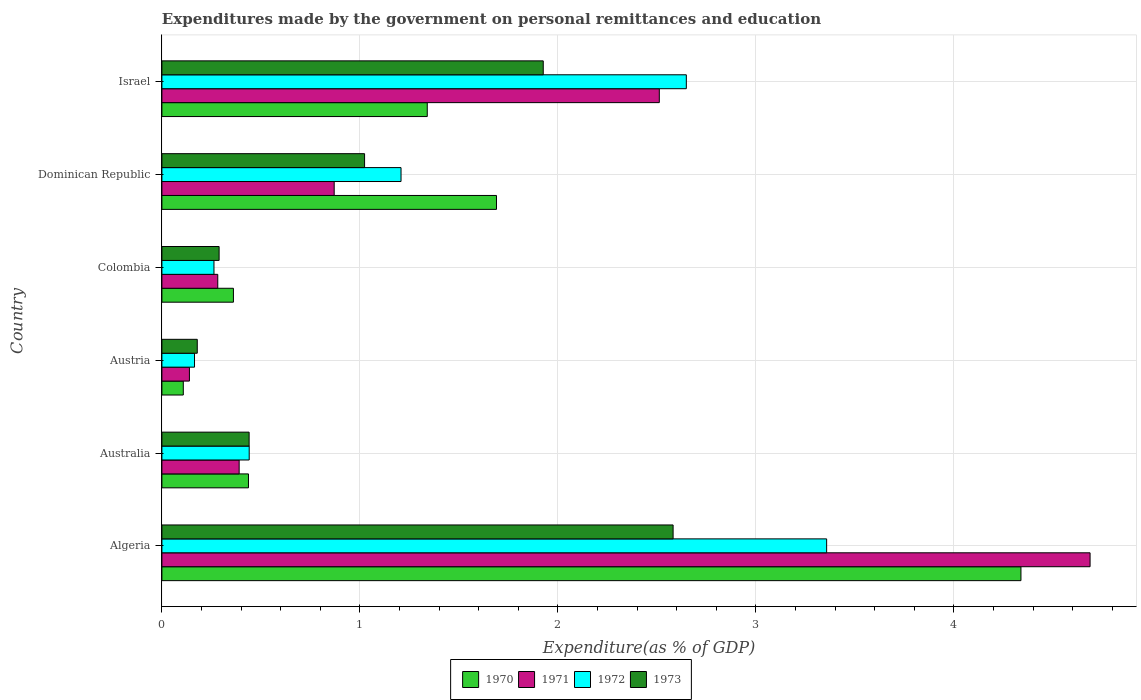How many different coloured bars are there?
Ensure brevity in your answer.  4. How many groups of bars are there?
Provide a short and direct response. 6. Are the number of bars per tick equal to the number of legend labels?
Provide a short and direct response. Yes. Are the number of bars on each tick of the Y-axis equal?
Ensure brevity in your answer.  Yes. How many bars are there on the 1st tick from the bottom?
Make the answer very short. 4. In how many cases, is the number of bars for a given country not equal to the number of legend labels?
Offer a very short reply. 0. What is the expenditures made by the government on personal remittances and education in 1970 in Austria?
Offer a terse response. 0.11. Across all countries, what is the maximum expenditures made by the government on personal remittances and education in 1973?
Keep it short and to the point. 2.58. Across all countries, what is the minimum expenditures made by the government on personal remittances and education in 1972?
Your answer should be compact. 0.16. In which country was the expenditures made by the government on personal remittances and education in 1970 maximum?
Ensure brevity in your answer.  Algeria. What is the total expenditures made by the government on personal remittances and education in 1970 in the graph?
Ensure brevity in your answer.  8.27. What is the difference between the expenditures made by the government on personal remittances and education in 1973 in Dominican Republic and that in Israel?
Make the answer very short. -0.9. What is the difference between the expenditures made by the government on personal remittances and education in 1970 in Dominican Republic and the expenditures made by the government on personal remittances and education in 1972 in Algeria?
Your response must be concise. -1.67. What is the average expenditures made by the government on personal remittances and education in 1970 per country?
Offer a very short reply. 1.38. What is the difference between the expenditures made by the government on personal remittances and education in 1973 and expenditures made by the government on personal remittances and education in 1970 in Israel?
Provide a succinct answer. 0.59. In how many countries, is the expenditures made by the government on personal remittances and education in 1971 greater than 3.6 %?
Provide a short and direct response. 1. What is the ratio of the expenditures made by the government on personal remittances and education in 1973 in Colombia to that in Dominican Republic?
Ensure brevity in your answer.  0.28. What is the difference between the highest and the second highest expenditures made by the government on personal remittances and education in 1971?
Offer a very short reply. 2.18. What is the difference between the highest and the lowest expenditures made by the government on personal remittances and education in 1971?
Keep it short and to the point. 4.55. In how many countries, is the expenditures made by the government on personal remittances and education in 1971 greater than the average expenditures made by the government on personal remittances and education in 1971 taken over all countries?
Ensure brevity in your answer.  2. Is the sum of the expenditures made by the government on personal remittances and education in 1971 in Colombia and Israel greater than the maximum expenditures made by the government on personal remittances and education in 1972 across all countries?
Your answer should be compact. No. Is it the case that in every country, the sum of the expenditures made by the government on personal remittances and education in 1971 and expenditures made by the government on personal remittances and education in 1973 is greater than the sum of expenditures made by the government on personal remittances and education in 1970 and expenditures made by the government on personal remittances and education in 1972?
Offer a very short reply. No. Is it the case that in every country, the sum of the expenditures made by the government on personal remittances and education in 1971 and expenditures made by the government on personal remittances and education in 1973 is greater than the expenditures made by the government on personal remittances and education in 1972?
Give a very brief answer. Yes. How many countries are there in the graph?
Give a very brief answer. 6. What is the difference between two consecutive major ticks on the X-axis?
Provide a succinct answer. 1. Are the values on the major ticks of X-axis written in scientific E-notation?
Your response must be concise. No. Does the graph contain any zero values?
Offer a terse response. No. Does the graph contain grids?
Your response must be concise. Yes. Where does the legend appear in the graph?
Your answer should be compact. Bottom center. How many legend labels are there?
Ensure brevity in your answer.  4. How are the legend labels stacked?
Ensure brevity in your answer.  Horizontal. What is the title of the graph?
Your answer should be very brief. Expenditures made by the government on personal remittances and education. What is the label or title of the X-axis?
Offer a very short reply. Expenditure(as % of GDP). What is the label or title of the Y-axis?
Your response must be concise. Country. What is the Expenditure(as % of GDP) of 1970 in Algeria?
Offer a terse response. 4.34. What is the Expenditure(as % of GDP) in 1971 in Algeria?
Keep it short and to the point. 4.69. What is the Expenditure(as % of GDP) of 1972 in Algeria?
Provide a succinct answer. 3.36. What is the Expenditure(as % of GDP) of 1973 in Algeria?
Make the answer very short. 2.58. What is the Expenditure(as % of GDP) in 1970 in Australia?
Your response must be concise. 0.44. What is the Expenditure(as % of GDP) of 1971 in Australia?
Keep it short and to the point. 0.39. What is the Expenditure(as % of GDP) of 1972 in Australia?
Keep it short and to the point. 0.44. What is the Expenditure(as % of GDP) of 1973 in Australia?
Your answer should be very brief. 0.44. What is the Expenditure(as % of GDP) of 1970 in Austria?
Provide a succinct answer. 0.11. What is the Expenditure(as % of GDP) in 1971 in Austria?
Offer a terse response. 0.14. What is the Expenditure(as % of GDP) in 1972 in Austria?
Offer a very short reply. 0.16. What is the Expenditure(as % of GDP) of 1973 in Austria?
Your answer should be very brief. 0.18. What is the Expenditure(as % of GDP) of 1970 in Colombia?
Provide a short and direct response. 0.36. What is the Expenditure(as % of GDP) in 1971 in Colombia?
Your response must be concise. 0.28. What is the Expenditure(as % of GDP) of 1972 in Colombia?
Your response must be concise. 0.26. What is the Expenditure(as % of GDP) of 1973 in Colombia?
Offer a terse response. 0.29. What is the Expenditure(as % of GDP) of 1970 in Dominican Republic?
Keep it short and to the point. 1.69. What is the Expenditure(as % of GDP) in 1971 in Dominican Republic?
Provide a short and direct response. 0.87. What is the Expenditure(as % of GDP) of 1972 in Dominican Republic?
Offer a terse response. 1.21. What is the Expenditure(as % of GDP) in 1973 in Dominican Republic?
Provide a succinct answer. 1.02. What is the Expenditure(as % of GDP) of 1970 in Israel?
Your response must be concise. 1.34. What is the Expenditure(as % of GDP) of 1971 in Israel?
Give a very brief answer. 2.51. What is the Expenditure(as % of GDP) of 1972 in Israel?
Your answer should be compact. 2.65. What is the Expenditure(as % of GDP) in 1973 in Israel?
Provide a short and direct response. 1.93. Across all countries, what is the maximum Expenditure(as % of GDP) of 1970?
Provide a short and direct response. 4.34. Across all countries, what is the maximum Expenditure(as % of GDP) in 1971?
Offer a terse response. 4.69. Across all countries, what is the maximum Expenditure(as % of GDP) of 1972?
Your response must be concise. 3.36. Across all countries, what is the maximum Expenditure(as % of GDP) in 1973?
Your response must be concise. 2.58. Across all countries, what is the minimum Expenditure(as % of GDP) in 1970?
Keep it short and to the point. 0.11. Across all countries, what is the minimum Expenditure(as % of GDP) of 1971?
Provide a succinct answer. 0.14. Across all countries, what is the minimum Expenditure(as % of GDP) in 1972?
Offer a very short reply. 0.16. Across all countries, what is the minimum Expenditure(as % of GDP) in 1973?
Your response must be concise. 0.18. What is the total Expenditure(as % of GDP) of 1970 in the graph?
Keep it short and to the point. 8.27. What is the total Expenditure(as % of GDP) in 1971 in the graph?
Keep it short and to the point. 8.88. What is the total Expenditure(as % of GDP) in 1972 in the graph?
Keep it short and to the point. 8.08. What is the total Expenditure(as % of GDP) of 1973 in the graph?
Your response must be concise. 6.44. What is the difference between the Expenditure(as % of GDP) of 1970 in Algeria and that in Australia?
Give a very brief answer. 3.9. What is the difference between the Expenditure(as % of GDP) in 1971 in Algeria and that in Australia?
Ensure brevity in your answer.  4.3. What is the difference between the Expenditure(as % of GDP) of 1972 in Algeria and that in Australia?
Your answer should be compact. 2.92. What is the difference between the Expenditure(as % of GDP) in 1973 in Algeria and that in Australia?
Offer a very short reply. 2.14. What is the difference between the Expenditure(as % of GDP) in 1970 in Algeria and that in Austria?
Give a very brief answer. 4.23. What is the difference between the Expenditure(as % of GDP) in 1971 in Algeria and that in Austria?
Ensure brevity in your answer.  4.55. What is the difference between the Expenditure(as % of GDP) in 1972 in Algeria and that in Austria?
Provide a succinct answer. 3.19. What is the difference between the Expenditure(as % of GDP) of 1973 in Algeria and that in Austria?
Provide a short and direct response. 2.4. What is the difference between the Expenditure(as % of GDP) in 1970 in Algeria and that in Colombia?
Your answer should be compact. 3.98. What is the difference between the Expenditure(as % of GDP) of 1971 in Algeria and that in Colombia?
Keep it short and to the point. 4.41. What is the difference between the Expenditure(as % of GDP) in 1972 in Algeria and that in Colombia?
Ensure brevity in your answer.  3.09. What is the difference between the Expenditure(as % of GDP) of 1973 in Algeria and that in Colombia?
Ensure brevity in your answer.  2.29. What is the difference between the Expenditure(as % of GDP) in 1970 in Algeria and that in Dominican Republic?
Give a very brief answer. 2.65. What is the difference between the Expenditure(as % of GDP) of 1971 in Algeria and that in Dominican Republic?
Provide a short and direct response. 3.82. What is the difference between the Expenditure(as % of GDP) in 1972 in Algeria and that in Dominican Republic?
Give a very brief answer. 2.15. What is the difference between the Expenditure(as % of GDP) of 1973 in Algeria and that in Dominican Republic?
Your answer should be compact. 1.56. What is the difference between the Expenditure(as % of GDP) in 1970 in Algeria and that in Israel?
Give a very brief answer. 3. What is the difference between the Expenditure(as % of GDP) in 1971 in Algeria and that in Israel?
Give a very brief answer. 2.18. What is the difference between the Expenditure(as % of GDP) of 1972 in Algeria and that in Israel?
Keep it short and to the point. 0.71. What is the difference between the Expenditure(as % of GDP) in 1973 in Algeria and that in Israel?
Offer a terse response. 0.66. What is the difference between the Expenditure(as % of GDP) in 1970 in Australia and that in Austria?
Make the answer very short. 0.33. What is the difference between the Expenditure(as % of GDP) of 1971 in Australia and that in Austria?
Ensure brevity in your answer.  0.25. What is the difference between the Expenditure(as % of GDP) in 1972 in Australia and that in Austria?
Your response must be concise. 0.28. What is the difference between the Expenditure(as % of GDP) of 1973 in Australia and that in Austria?
Offer a very short reply. 0.26. What is the difference between the Expenditure(as % of GDP) in 1970 in Australia and that in Colombia?
Make the answer very short. 0.08. What is the difference between the Expenditure(as % of GDP) in 1971 in Australia and that in Colombia?
Your answer should be compact. 0.11. What is the difference between the Expenditure(as % of GDP) in 1972 in Australia and that in Colombia?
Offer a very short reply. 0.18. What is the difference between the Expenditure(as % of GDP) in 1973 in Australia and that in Colombia?
Your response must be concise. 0.15. What is the difference between the Expenditure(as % of GDP) in 1970 in Australia and that in Dominican Republic?
Your response must be concise. -1.25. What is the difference between the Expenditure(as % of GDP) in 1971 in Australia and that in Dominican Republic?
Your answer should be compact. -0.48. What is the difference between the Expenditure(as % of GDP) of 1972 in Australia and that in Dominican Republic?
Give a very brief answer. -0.77. What is the difference between the Expenditure(as % of GDP) in 1973 in Australia and that in Dominican Republic?
Offer a terse response. -0.58. What is the difference between the Expenditure(as % of GDP) in 1970 in Australia and that in Israel?
Your answer should be very brief. -0.9. What is the difference between the Expenditure(as % of GDP) in 1971 in Australia and that in Israel?
Ensure brevity in your answer.  -2.12. What is the difference between the Expenditure(as % of GDP) of 1972 in Australia and that in Israel?
Offer a very short reply. -2.21. What is the difference between the Expenditure(as % of GDP) of 1973 in Australia and that in Israel?
Give a very brief answer. -1.49. What is the difference between the Expenditure(as % of GDP) in 1970 in Austria and that in Colombia?
Offer a terse response. -0.25. What is the difference between the Expenditure(as % of GDP) of 1971 in Austria and that in Colombia?
Keep it short and to the point. -0.14. What is the difference between the Expenditure(as % of GDP) of 1972 in Austria and that in Colombia?
Offer a very short reply. -0.1. What is the difference between the Expenditure(as % of GDP) of 1973 in Austria and that in Colombia?
Keep it short and to the point. -0.11. What is the difference between the Expenditure(as % of GDP) in 1970 in Austria and that in Dominican Republic?
Keep it short and to the point. -1.58. What is the difference between the Expenditure(as % of GDP) of 1971 in Austria and that in Dominican Republic?
Your answer should be very brief. -0.73. What is the difference between the Expenditure(as % of GDP) of 1972 in Austria and that in Dominican Republic?
Your answer should be compact. -1.04. What is the difference between the Expenditure(as % of GDP) of 1973 in Austria and that in Dominican Republic?
Provide a succinct answer. -0.84. What is the difference between the Expenditure(as % of GDP) of 1970 in Austria and that in Israel?
Offer a terse response. -1.23. What is the difference between the Expenditure(as % of GDP) of 1971 in Austria and that in Israel?
Your answer should be compact. -2.37. What is the difference between the Expenditure(as % of GDP) in 1972 in Austria and that in Israel?
Keep it short and to the point. -2.48. What is the difference between the Expenditure(as % of GDP) of 1973 in Austria and that in Israel?
Your answer should be very brief. -1.75. What is the difference between the Expenditure(as % of GDP) in 1970 in Colombia and that in Dominican Republic?
Make the answer very short. -1.33. What is the difference between the Expenditure(as % of GDP) of 1971 in Colombia and that in Dominican Republic?
Give a very brief answer. -0.59. What is the difference between the Expenditure(as % of GDP) of 1972 in Colombia and that in Dominican Republic?
Your response must be concise. -0.94. What is the difference between the Expenditure(as % of GDP) of 1973 in Colombia and that in Dominican Republic?
Keep it short and to the point. -0.73. What is the difference between the Expenditure(as % of GDP) in 1970 in Colombia and that in Israel?
Give a very brief answer. -0.98. What is the difference between the Expenditure(as % of GDP) in 1971 in Colombia and that in Israel?
Keep it short and to the point. -2.23. What is the difference between the Expenditure(as % of GDP) in 1972 in Colombia and that in Israel?
Your answer should be compact. -2.39. What is the difference between the Expenditure(as % of GDP) of 1973 in Colombia and that in Israel?
Ensure brevity in your answer.  -1.64. What is the difference between the Expenditure(as % of GDP) of 1970 in Dominican Republic and that in Israel?
Your answer should be very brief. 0.35. What is the difference between the Expenditure(as % of GDP) of 1971 in Dominican Republic and that in Israel?
Offer a terse response. -1.64. What is the difference between the Expenditure(as % of GDP) of 1972 in Dominican Republic and that in Israel?
Ensure brevity in your answer.  -1.44. What is the difference between the Expenditure(as % of GDP) in 1973 in Dominican Republic and that in Israel?
Ensure brevity in your answer.  -0.9. What is the difference between the Expenditure(as % of GDP) of 1970 in Algeria and the Expenditure(as % of GDP) of 1971 in Australia?
Your answer should be compact. 3.95. What is the difference between the Expenditure(as % of GDP) in 1970 in Algeria and the Expenditure(as % of GDP) in 1972 in Australia?
Make the answer very short. 3.9. What is the difference between the Expenditure(as % of GDP) of 1970 in Algeria and the Expenditure(as % of GDP) of 1973 in Australia?
Provide a succinct answer. 3.9. What is the difference between the Expenditure(as % of GDP) in 1971 in Algeria and the Expenditure(as % of GDP) in 1972 in Australia?
Provide a short and direct response. 4.25. What is the difference between the Expenditure(as % of GDP) of 1971 in Algeria and the Expenditure(as % of GDP) of 1973 in Australia?
Ensure brevity in your answer.  4.25. What is the difference between the Expenditure(as % of GDP) in 1972 in Algeria and the Expenditure(as % of GDP) in 1973 in Australia?
Ensure brevity in your answer.  2.92. What is the difference between the Expenditure(as % of GDP) of 1970 in Algeria and the Expenditure(as % of GDP) of 1971 in Austria?
Give a very brief answer. 4.2. What is the difference between the Expenditure(as % of GDP) of 1970 in Algeria and the Expenditure(as % of GDP) of 1972 in Austria?
Provide a succinct answer. 4.17. What is the difference between the Expenditure(as % of GDP) of 1970 in Algeria and the Expenditure(as % of GDP) of 1973 in Austria?
Ensure brevity in your answer.  4.16. What is the difference between the Expenditure(as % of GDP) in 1971 in Algeria and the Expenditure(as % of GDP) in 1972 in Austria?
Offer a terse response. 4.52. What is the difference between the Expenditure(as % of GDP) of 1971 in Algeria and the Expenditure(as % of GDP) of 1973 in Austria?
Keep it short and to the point. 4.51. What is the difference between the Expenditure(as % of GDP) in 1972 in Algeria and the Expenditure(as % of GDP) in 1973 in Austria?
Offer a very short reply. 3.18. What is the difference between the Expenditure(as % of GDP) in 1970 in Algeria and the Expenditure(as % of GDP) in 1971 in Colombia?
Ensure brevity in your answer.  4.06. What is the difference between the Expenditure(as % of GDP) of 1970 in Algeria and the Expenditure(as % of GDP) of 1972 in Colombia?
Ensure brevity in your answer.  4.08. What is the difference between the Expenditure(as % of GDP) of 1970 in Algeria and the Expenditure(as % of GDP) of 1973 in Colombia?
Offer a very short reply. 4.05. What is the difference between the Expenditure(as % of GDP) of 1971 in Algeria and the Expenditure(as % of GDP) of 1972 in Colombia?
Your answer should be compact. 4.42. What is the difference between the Expenditure(as % of GDP) of 1971 in Algeria and the Expenditure(as % of GDP) of 1973 in Colombia?
Your answer should be very brief. 4.4. What is the difference between the Expenditure(as % of GDP) in 1972 in Algeria and the Expenditure(as % of GDP) in 1973 in Colombia?
Provide a succinct answer. 3.07. What is the difference between the Expenditure(as % of GDP) in 1970 in Algeria and the Expenditure(as % of GDP) in 1971 in Dominican Republic?
Give a very brief answer. 3.47. What is the difference between the Expenditure(as % of GDP) in 1970 in Algeria and the Expenditure(as % of GDP) in 1972 in Dominican Republic?
Provide a succinct answer. 3.13. What is the difference between the Expenditure(as % of GDP) in 1970 in Algeria and the Expenditure(as % of GDP) in 1973 in Dominican Republic?
Make the answer very short. 3.31. What is the difference between the Expenditure(as % of GDP) in 1971 in Algeria and the Expenditure(as % of GDP) in 1972 in Dominican Republic?
Ensure brevity in your answer.  3.48. What is the difference between the Expenditure(as % of GDP) of 1971 in Algeria and the Expenditure(as % of GDP) of 1973 in Dominican Republic?
Make the answer very short. 3.66. What is the difference between the Expenditure(as % of GDP) of 1972 in Algeria and the Expenditure(as % of GDP) of 1973 in Dominican Republic?
Give a very brief answer. 2.33. What is the difference between the Expenditure(as % of GDP) of 1970 in Algeria and the Expenditure(as % of GDP) of 1971 in Israel?
Give a very brief answer. 1.83. What is the difference between the Expenditure(as % of GDP) of 1970 in Algeria and the Expenditure(as % of GDP) of 1972 in Israel?
Give a very brief answer. 1.69. What is the difference between the Expenditure(as % of GDP) of 1970 in Algeria and the Expenditure(as % of GDP) of 1973 in Israel?
Provide a succinct answer. 2.41. What is the difference between the Expenditure(as % of GDP) in 1971 in Algeria and the Expenditure(as % of GDP) in 1972 in Israel?
Make the answer very short. 2.04. What is the difference between the Expenditure(as % of GDP) in 1971 in Algeria and the Expenditure(as % of GDP) in 1973 in Israel?
Offer a very short reply. 2.76. What is the difference between the Expenditure(as % of GDP) in 1972 in Algeria and the Expenditure(as % of GDP) in 1973 in Israel?
Ensure brevity in your answer.  1.43. What is the difference between the Expenditure(as % of GDP) of 1970 in Australia and the Expenditure(as % of GDP) of 1971 in Austria?
Provide a succinct answer. 0.3. What is the difference between the Expenditure(as % of GDP) in 1970 in Australia and the Expenditure(as % of GDP) in 1972 in Austria?
Your response must be concise. 0.27. What is the difference between the Expenditure(as % of GDP) of 1970 in Australia and the Expenditure(as % of GDP) of 1973 in Austria?
Your answer should be compact. 0.26. What is the difference between the Expenditure(as % of GDP) in 1971 in Australia and the Expenditure(as % of GDP) in 1972 in Austria?
Make the answer very short. 0.23. What is the difference between the Expenditure(as % of GDP) of 1971 in Australia and the Expenditure(as % of GDP) of 1973 in Austria?
Ensure brevity in your answer.  0.21. What is the difference between the Expenditure(as % of GDP) in 1972 in Australia and the Expenditure(as % of GDP) in 1973 in Austria?
Give a very brief answer. 0.26. What is the difference between the Expenditure(as % of GDP) in 1970 in Australia and the Expenditure(as % of GDP) in 1971 in Colombia?
Your answer should be compact. 0.15. What is the difference between the Expenditure(as % of GDP) in 1970 in Australia and the Expenditure(as % of GDP) in 1972 in Colombia?
Keep it short and to the point. 0.17. What is the difference between the Expenditure(as % of GDP) of 1970 in Australia and the Expenditure(as % of GDP) of 1973 in Colombia?
Provide a succinct answer. 0.15. What is the difference between the Expenditure(as % of GDP) of 1971 in Australia and the Expenditure(as % of GDP) of 1972 in Colombia?
Your response must be concise. 0.13. What is the difference between the Expenditure(as % of GDP) in 1971 in Australia and the Expenditure(as % of GDP) in 1973 in Colombia?
Your answer should be compact. 0.1. What is the difference between the Expenditure(as % of GDP) in 1972 in Australia and the Expenditure(as % of GDP) in 1973 in Colombia?
Make the answer very short. 0.15. What is the difference between the Expenditure(as % of GDP) in 1970 in Australia and the Expenditure(as % of GDP) in 1971 in Dominican Republic?
Offer a terse response. -0.43. What is the difference between the Expenditure(as % of GDP) in 1970 in Australia and the Expenditure(as % of GDP) in 1972 in Dominican Republic?
Provide a short and direct response. -0.77. What is the difference between the Expenditure(as % of GDP) in 1970 in Australia and the Expenditure(as % of GDP) in 1973 in Dominican Republic?
Give a very brief answer. -0.59. What is the difference between the Expenditure(as % of GDP) in 1971 in Australia and the Expenditure(as % of GDP) in 1972 in Dominican Republic?
Provide a short and direct response. -0.82. What is the difference between the Expenditure(as % of GDP) in 1971 in Australia and the Expenditure(as % of GDP) in 1973 in Dominican Republic?
Make the answer very short. -0.63. What is the difference between the Expenditure(as % of GDP) of 1972 in Australia and the Expenditure(as % of GDP) of 1973 in Dominican Republic?
Your answer should be very brief. -0.58. What is the difference between the Expenditure(as % of GDP) in 1970 in Australia and the Expenditure(as % of GDP) in 1971 in Israel?
Make the answer very short. -2.07. What is the difference between the Expenditure(as % of GDP) of 1970 in Australia and the Expenditure(as % of GDP) of 1972 in Israel?
Give a very brief answer. -2.21. What is the difference between the Expenditure(as % of GDP) of 1970 in Australia and the Expenditure(as % of GDP) of 1973 in Israel?
Provide a short and direct response. -1.49. What is the difference between the Expenditure(as % of GDP) in 1971 in Australia and the Expenditure(as % of GDP) in 1972 in Israel?
Provide a short and direct response. -2.26. What is the difference between the Expenditure(as % of GDP) of 1971 in Australia and the Expenditure(as % of GDP) of 1973 in Israel?
Give a very brief answer. -1.54. What is the difference between the Expenditure(as % of GDP) of 1972 in Australia and the Expenditure(as % of GDP) of 1973 in Israel?
Make the answer very short. -1.49. What is the difference between the Expenditure(as % of GDP) in 1970 in Austria and the Expenditure(as % of GDP) in 1971 in Colombia?
Your answer should be compact. -0.17. What is the difference between the Expenditure(as % of GDP) in 1970 in Austria and the Expenditure(as % of GDP) in 1972 in Colombia?
Your answer should be very brief. -0.15. What is the difference between the Expenditure(as % of GDP) in 1970 in Austria and the Expenditure(as % of GDP) in 1973 in Colombia?
Your response must be concise. -0.18. What is the difference between the Expenditure(as % of GDP) in 1971 in Austria and the Expenditure(as % of GDP) in 1972 in Colombia?
Provide a succinct answer. -0.12. What is the difference between the Expenditure(as % of GDP) of 1971 in Austria and the Expenditure(as % of GDP) of 1973 in Colombia?
Make the answer very short. -0.15. What is the difference between the Expenditure(as % of GDP) in 1972 in Austria and the Expenditure(as % of GDP) in 1973 in Colombia?
Offer a terse response. -0.12. What is the difference between the Expenditure(as % of GDP) of 1970 in Austria and the Expenditure(as % of GDP) of 1971 in Dominican Republic?
Provide a succinct answer. -0.76. What is the difference between the Expenditure(as % of GDP) in 1970 in Austria and the Expenditure(as % of GDP) in 1972 in Dominican Republic?
Make the answer very short. -1.1. What is the difference between the Expenditure(as % of GDP) in 1970 in Austria and the Expenditure(as % of GDP) in 1973 in Dominican Republic?
Ensure brevity in your answer.  -0.92. What is the difference between the Expenditure(as % of GDP) of 1971 in Austria and the Expenditure(as % of GDP) of 1972 in Dominican Republic?
Offer a terse response. -1.07. What is the difference between the Expenditure(as % of GDP) in 1971 in Austria and the Expenditure(as % of GDP) in 1973 in Dominican Republic?
Give a very brief answer. -0.88. What is the difference between the Expenditure(as % of GDP) of 1972 in Austria and the Expenditure(as % of GDP) of 1973 in Dominican Republic?
Give a very brief answer. -0.86. What is the difference between the Expenditure(as % of GDP) of 1970 in Austria and the Expenditure(as % of GDP) of 1971 in Israel?
Provide a short and direct response. -2.4. What is the difference between the Expenditure(as % of GDP) in 1970 in Austria and the Expenditure(as % of GDP) in 1972 in Israel?
Ensure brevity in your answer.  -2.54. What is the difference between the Expenditure(as % of GDP) of 1970 in Austria and the Expenditure(as % of GDP) of 1973 in Israel?
Offer a terse response. -1.82. What is the difference between the Expenditure(as % of GDP) of 1971 in Austria and the Expenditure(as % of GDP) of 1972 in Israel?
Provide a succinct answer. -2.51. What is the difference between the Expenditure(as % of GDP) of 1971 in Austria and the Expenditure(as % of GDP) of 1973 in Israel?
Your answer should be very brief. -1.79. What is the difference between the Expenditure(as % of GDP) of 1972 in Austria and the Expenditure(as % of GDP) of 1973 in Israel?
Keep it short and to the point. -1.76. What is the difference between the Expenditure(as % of GDP) in 1970 in Colombia and the Expenditure(as % of GDP) in 1971 in Dominican Republic?
Your answer should be very brief. -0.51. What is the difference between the Expenditure(as % of GDP) in 1970 in Colombia and the Expenditure(as % of GDP) in 1972 in Dominican Republic?
Give a very brief answer. -0.85. What is the difference between the Expenditure(as % of GDP) in 1970 in Colombia and the Expenditure(as % of GDP) in 1973 in Dominican Republic?
Make the answer very short. -0.66. What is the difference between the Expenditure(as % of GDP) in 1971 in Colombia and the Expenditure(as % of GDP) in 1972 in Dominican Republic?
Make the answer very short. -0.93. What is the difference between the Expenditure(as % of GDP) in 1971 in Colombia and the Expenditure(as % of GDP) in 1973 in Dominican Republic?
Offer a very short reply. -0.74. What is the difference between the Expenditure(as % of GDP) of 1972 in Colombia and the Expenditure(as % of GDP) of 1973 in Dominican Republic?
Ensure brevity in your answer.  -0.76. What is the difference between the Expenditure(as % of GDP) in 1970 in Colombia and the Expenditure(as % of GDP) in 1971 in Israel?
Make the answer very short. -2.15. What is the difference between the Expenditure(as % of GDP) in 1970 in Colombia and the Expenditure(as % of GDP) in 1972 in Israel?
Give a very brief answer. -2.29. What is the difference between the Expenditure(as % of GDP) of 1970 in Colombia and the Expenditure(as % of GDP) of 1973 in Israel?
Offer a very short reply. -1.56. What is the difference between the Expenditure(as % of GDP) of 1971 in Colombia and the Expenditure(as % of GDP) of 1972 in Israel?
Offer a terse response. -2.37. What is the difference between the Expenditure(as % of GDP) in 1971 in Colombia and the Expenditure(as % of GDP) in 1973 in Israel?
Offer a very short reply. -1.64. What is the difference between the Expenditure(as % of GDP) of 1972 in Colombia and the Expenditure(as % of GDP) of 1973 in Israel?
Offer a very short reply. -1.66. What is the difference between the Expenditure(as % of GDP) of 1970 in Dominican Republic and the Expenditure(as % of GDP) of 1971 in Israel?
Ensure brevity in your answer.  -0.82. What is the difference between the Expenditure(as % of GDP) of 1970 in Dominican Republic and the Expenditure(as % of GDP) of 1972 in Israel?
Provide a succinct answer. -0.96. What is the difference between the Expenditure(as % of GDP) in 1970 in Dominican Republic and the Expenditure(as % of GDP) in 1973 in Israel?
Provide a short and direct response. -0.24. What is the difference between the Expenditure(as % of GDP) of 1971 in Dominican Republic and the Expenditure(as % of GDP) of 1972 in Israel?
Provide a succinct answer. -1.78. What is the difference between the Expenditure(as % of GDP) of 1971 in Dominican Republic and the Expenditure(as % of GDP) of 1973 in Israel?
Keep it short and to the point. -1.06. What is the difference between the Expenditure(as % of GDP) of 1972 in Dominican Republic and the Expenditure(as % of GDP) of 1973 in Israel?
Provide a succinct answer. -0.72. What is the average Expenditure(as % of GDP) of 1970 per country?
Give a very brief answer. 1.38. What is the average Expenditure(as % of GDP) of 1971 per country?
Give a very brief answer. 1.48. What is the average Expenditure(as % of GDP) of 1972 per country?
Your answer should be compact. 1.35. What is the average Expenditure(as % of GDP) in 1973 per country?
Your answer should be compact. 1.07. What is the difference between the Expenditure(as % of GDP) in 1970 and Expenditure(as % of GDP) in 1971 in Algeria?
Provide a short and direct response. -0.35. What is the difference between the Expenditure(as % of GDP) of 1970 and Expenditure(as % of GDP) of 1972 in Algeria?
Offer a terse response. 0.98. What is the difference between the Expenditure(as % of GDP) of 1970 and Expenditure(as % of GDP) of 1973 in Algeria?
Give a very brief answer. 1.76. What is the difference between the Expenditure(as % of GDP) in 1971 and Expenditure(as % of GDP) in 1972 in Algeria?
Offer a very short reply. 1.33. What is the difference between the Expenditure(as % of GDP) in 1971 and Expenditure(as % of GDP) in 1973 in Algeria?
Ensure brevity in your answer.  2.11. What is the difference between the Expenditure(as % of GDP) in 1972 and Expenditure(as % of GDP) in 1973 in Algeria?
Your answer should be very brief. 0.78. What is the difference between the Expenditure(as % of GDP) of 1970 and Expenditure(as % of GDP) of 1971 in Australia?
Your response must be concise. 0.05. What is the difference between the Expenditure(as % of GDP) of 1970 and Expenditure(as % of GDP) of 1972 in Australia?
Provide a short and direct response. -0. What is the difference between the Expenditure(as % of GDP) in 1970 and Expenditure(as % of GDP) in 1973 in Australia?
Make the answer very short. -0. What is the difference between the Expenditure(as % of GDP) of 1971 and Expenditure(as % of GDP) of 1972 in Australia?
Give a very brief answer. -0.05. What is the difference between the Expenditure(as % of GDP) of 1971 and Expenditure(as % of GDP) of 1973 in Australia?
Provide a succinct answer. -0.05. What is the difference between the Expenditure(as % of GDP) of 1972 and Expenditure(as % of GDP) of 1973 in Australia?
Provide a succinct answer. 0. What is the difference between the Expenditure(as % of GDP) in 1970 and Expenditure(as % of GDP) in 1971 in Austria?
Ensure brevity in your answer.  -0.03. What is the difference between the Expenditure(as % of GDP) in 1970 and Expenditure(as % of GDP) in 1972 in Austria?
Give a very brief answer. -0.06. What is the difference between the Expenditure(as % of GDP) of 1970 and Expenditure(as % of GDP) of 1973 in Austria?
Ensure brevity in your answer.  -0.07. What is the difference between the Expenditure(as % of GDP) in 1971 and Expenditure(as % of GDP) in 1972 in Austria?
Provide a succinct answer. -0.03. What is the difference between the Expenditure(as % of GDP) in 1971 and Expenditure(as % of GDP) in 1973 in Austria?
Your response must be concise. -0.04. What is the difference between the Expenditure(as % of GDP) of 1972 and Expenditure(as % of GDP) of 1973 in Austria?
Your answer should be compact. -0.01. What is the difference between the Expenditure(as % of GDP) in 1970 and Expenditure(as % of GDP) in 1971 in Colombia?
Keep it short and to the point. 0.08. What is the difference between the Expenditure(as % of GDP) of 1970 and Expenditure(as % of GDP) of 1972 in Colombia?
Provide a succinct answer. 0.1. What is the difference between the Expenditure(as % of GDP) of 1970 and Expenditure(as % of GDP) of 1973 in Colombia?
Offer a very short reply. 0.07. What is the difference between the Expenditure(as % of GDP) in 1971 and Expenditure(as % of GDP) in 1972 in Colombia?
Make the answer very short. 0.02. What is the difference between the Expenditure(as % of GDP) in 1971 and Expenditure(as % of GDP) in 1973 in Colombia?
Your answer should be very brief. -0.01. What is the difference between the Expenditure(as % of GDP) in 1972 and Expenditure(as % of GDP) in 1973 in Colombia?
Ensure brevity in your answer.  -0.03. What is the difference between the Expenditure(as % of GDP) of 1970 and Expenditure(as % of GDP) of 1971 in Dominican Republic?
Ensure brevity in your answer.  0.82. What is the difference between the Expenditure(as % of GDP) of 1970 and Expenditure(as % of GDP) of 1972 in Dominican Republic?
Provide a succinct answer. 0.48. What is the difference between the Expenditure(as % of GDP) of 1970 and Expenditure(as % of GDP) of 1973 in Dominican Republic?
Keep it short and to the point. 0.67. What is the difference between the Expenditure(as % of GDP) of 1971 and Expenditure(as % of GDP) of 1972 in Dominican Republic?
Provide a succinct answer. -0.34. What is the difference between the Expenditure(as % of GDP) of 1971 and Expenditure(as % of GDP) of 1973 in Dominican Republic?
Your response must be concise. -0.15. What is the difference between the Expenditure(as % of GDP) in 1972 and Expenditure(as % of GDP) in 1973 in Dominican Republic?
Provide a succinct answer. 0.18. What is the difference between the Expenditure(as % of GDP) in 1970 and Expenditure(as % of GDP) in 1971 in Israel?
Offer a terse response. -1.17. What is the difference between the Expenditure(as % of GDP) in 1970 and Expenditure(as % of GDP) in 1972 in Israel?
Keep it short and to the point. -1.31. What is the difference between the Expenditure(as % of GDP) in 1970 and Expenditure(as % of GDP) in 1973 in Israel?
Offer a terse response. -0.59. What is the difference between the Expenditure(as % of GDP) of 1971 and Expenditure(as % of GDP) of 1972 in Israel?
Ensure brevity in your answer.  -0.14. What is the difference between the Expenditure(as % of GDP) in 1971 and Expenditure(as % of GDP) in 1973 in Israel?
Make the answer very short. 0.59. What is the difference between the Expenditure(as % of GDP) in 1972 and Expenditure(as % of GDP) in 1973 in Israel?
Keep it short and to the point. 0.72. What is the ratio of the Expenditure(as % of GDP) in 1970 in Algeria to that in Australia?
Make the answer very short. 9.92. What is the ratio of the Expenditure(as % of GDP) of 1971 in Algeria to that in Australia?
Offer a terse response. 12.01. What is the ratio of the Expenditure(as % of GDP) in 1972 in Algeria to that in Australia?
Ensure brevity in your answer.  7.61. What is the ratio of the Expenditure(as % of GDP) in 1973 in Algeria to that in Australia?
Make the answer very short. 5.86. What is the ratio of the Expenditure(as % of GDP) of 1970 in Algeria to that in Austria?
Offer a terse response. 40.14. What is the ratio of the Expenditure(as % of GDP) in 1971 in Algeria to that in Austria?
Make the answer very short. 33.73. What is the ratio of the Expenditure(as % of GDP) of 1972 in Algeria to that in Austria?
Give a very brief answer. 20.38. What is the ratio of the Expenditure(as % of GDP) in 1973 in Algeria to that in Austria?
Your answer should be compact. 14.45. What is the ratio of the Expenditure(as % of GDP) in 1970 in Algeria to that in Colombia?
Your answer should be compact. 12.01. What is the ratio of the Expenditure(as % of GDP) of 1971 in Algeria to that in Colombia?
Make the answer very short. 16.61. What is the ratio of the Expenditure(as % of GDP) of 1972 in Algeria to that in Colombia?
Provide a succinct answer. 12.77. What is the ratio of the Expenditure(as % of GDP) in 1973 in Algeria to that in Colombia?
Make the answer very short. 8.94. What is the ratio of the Expenditure(as % of GDP) of 1970 in Algeria to that in Dominican Republic?
Keep it short and to the point. 2.57. What is the ratio of the Expenditure(as % of GDP) of 1971 in Algeria to that in Dominican Republic?
Give a very brief answer. 5.39. What is the ratio of the Expenditure(as % of GDP) in 1972 in Algeria to that in Dominican Republic?
Give a very brief answer. 2.78. What is the ratio of the Expenditure(as % of GDP) in 1973 in Algeria to that in Dominican Republic?
Offer a terse response. 2.52. What is the ratio of the Expenditure(as % of GDP) of 1970 in Algeria to that in Israel?
Your response must be concise. 3.24. What is the ratio of the Expenditure(as % of GDP) in 1971 in Algeria to that in Israel?
Keep it short and to the point. 1.87. What is the ratio of the Expenditure(as % of GDP) in 1972 in Algeria to that in Israel?
Keep it short and to the point. 1.27. What is the ratio of the Expenditure(as % of GDP) of 1973 in Algeria to that in Israel?
Ensure brevity in your answer.  1.34. What is the ratio of the Expenditure(as % of GDP) in 1970 in Australia to that in Austria?
Your answer should be compact. 4.04. What is the ratio of the Expenditure(as % of GDP) in 1971 in Australia to that in Austria?
Your answer should be very brief. 2.81. What is the ratio of the Expenditure(as % of GDP) of 1972 in Australia to that in Austria?
Provide a short and direct response. 2.68. What is the ratio of the Expenditure(as % of GDP) of 1973 in Australia to that in Austria?
Your answer should be compact. 2.47. What is the ratio of the Expenditure(as % of GDP) of 1970 in Australia to that in Colombia?
Your answer should be very brief. 1.21. What is the ratio of the Expenditure(as % of GDP) of 1971 in Australia to that in Colombia?
Your response must be concise. 1.38. What is the ratio of the Expenditure(as % of GDP) in 1972 in Australia to that in Colombia?
Make the answer very short. 1.68. What is the ratio of the Expenditure(as % of GDP) of 1973 in Australia to that in Colombia?
Give a very brief answer. 1.52. What is the ratio of the Expenditure(as % of GDP) of 1970 in Australia to that in Dominican Republic?
Your answer should be compact. 0.26. What is the ratio of the Expenditure(as % of GDP) of 1971 in Australia to that in Dominican Republic?
Ensure brevity in your answer.  0.45. What is the ratio of the Expenditure(as % of GDP) of 1972 in Australia to that in Dominican Republic?
Your response must be concise. 0.37. What is the ratio of the Expenditure(as % of GDP) of 1973 in Australia to that in Dominican Republic?
Offer a very short reply. 0.43. What is the ratio of the Expenditure(as % of GDP) in 1970 in Australia to that in Israel?
Offer a very short reply. 0.33. What is the ratio of the Expenditure(as % of GDP) of 1971 in Australia to that in Israel?
Your response must be concise. 0.16. What is the ratio of the Expenditure(as % of GDP) of 1972 in Australia to that in Israel?
Keep it short and to the point. 0.17. What is the ratio of the Expenditure(as % of GDP) in 1973 in Australia to that in Israel?
Make the answer very short. 0.23. What is the ratio of the Expenditure(as % of GDP) of 1970 in Austria to that in Colombia?
Your response must be concise. 0.3. What is the ratio of the Expenditure(as % of GDP) in 1971 in Austria to that in Colombia?
Your answer should be very brief. 0.49. What is the ratio of the Expenditure(as % of GDP) of 1972 in Austria to that in Colombia?
Your response must be concise. 0.63. What is the ratio of the Expenditure(as % of GDP) in 1973 in Austria to that in Colombia?
Provide a succinct answer. 0.62. What is the ratio of the Expenditure(as % of GDP) in 1970 in Austria to that in Dominican Republic?
Keep it short and to the point. 0.06. What is the ratio of the Expenditure(as % of GDP) of 1971 in Austria to that in Dominican Republic?
Ensure brevity in your answer.  0.16. What is the ratio of the Expenditure(as % of GDP) in 1972 in Austria to that in Dominican Republic?
Give a very brief answer. 0.14. What is the ratio of the Expenditure(as % of GDP) of 1973 in Austria to that in Dominican Republic?
Keep it short and to the point. 0.17. What is the ratio of the Expenditure(as % of GDP) in 1970 in Austria to that in Israel?
Your response must be concise. 0.08. What is the ratio of the Expenditure(as % of GDP) in 1971 in Austria to that in Israel?
Your response must be concise. 0.06. What is the ratio of the Expenditure(as % of GDP) in 1972 in Austria to that in Israel?
Your answer should be very brief. 0.06. What is the ratio of the Expenditure(as % of GDP) of 1973 in Austria to that in Israel?
Offer a very short reply. 0.09. What is the ratio of the Expenditure(as % of GDP) of 1970 in Colombia to that in Dominican Republic?
Make the answer very short. 0.21. What is the ratio of the Expenditure(as % of GDP) of 1971 in Colombia to that in Dominican Republic?
Your answer should be compact. 0.32. What is the ratio of the Expenditure(as % of GDP) of 1972 in Colombia to that in Dominican Republic?
Provide a succinct answer. 0.22. What is the ratio of the Expenditure(as % of GDP) in 1973 in Colombia to that in Dominican Republic?
Provide a succinct answer. 0.28. What is the ratio of the Expenditure(as % of GDP) of 1970 in Colombia to that in Israel?
Ensure brevity in your answer.  0.27. What is the ratio of the Expenditure(as % of GDP) of 1971 in Colombia to that in Israel?
Your response must be concise. 0.11. What is the ratio of the Expenditure(as % of GDP) in 1972 in Colombia to that in Israel?
Ensure brevity in your answer.  0.1. What is the ratio of the Expenditure(as % of GDP) in 1970 in Dominican Republic to that in Israel?
Your answer should be very brief. 1.26. What is the ratio of the Expenditure(as % of GDP) of 1971 in Dominican Republic to that in Israel?
Your response must be concise. 0.35. What is the ratio of the Expenditure(as % of GDP) in 1972 in Dominican Republic to that in Israel?
Give a very brief answer. 0.46. What is the ratio of the Expenditure(as % of GDP) in 1973 in Dominican Republic to that in Israel?
Offer a terse response. 0.53. What is the difference between the highest and the second highest Expenditure(as % of GDP) of 1970?
Your response must be concise. 2.65. What is the difference between the highest and the second highest Expenditure(as % of GDP) in 1971?
Your answer should be compact. 2.18. What is the difference between the highest and the second highest Expenditure(as % of GDP) in 1972?
Offer a very short reply. 0.71. What is the difference between the highest and the second highest Expenditure(as % of GDP) in 1973?
Provide a succinct answer. 0.66. What is the difference between the highest and the lowest Expenditure(as % of GDP) of 1970?
Your answer should be compact. 4.23. What is the difference between the highest and the lowest Expenditure(as % of GDP) in 1971?
Ensure brevity in your answer.  4.55. What is the difference between the highest and the lowest Expenditure(as % of GDP) of 1972?
Your response must be concise. 3.19. What is the difference between the highest and the lowest Expenditure(as % of GDP) of 1973?
Your answer should be compact. 2.4. 